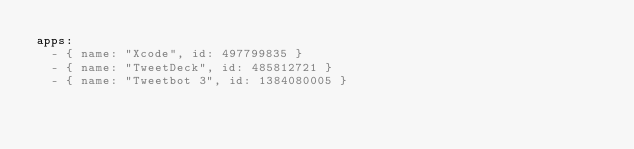Convert code to text. <code><loc_0><loc_0><loc_500><loc_500><_YAML_>apps:
  - { name: "Xcode", id: 497799835 }
  - { name: "TweetDeck", id: 485812721 }
  - { name: "Tweetbot 3", id: 1384080005 }
</code> 